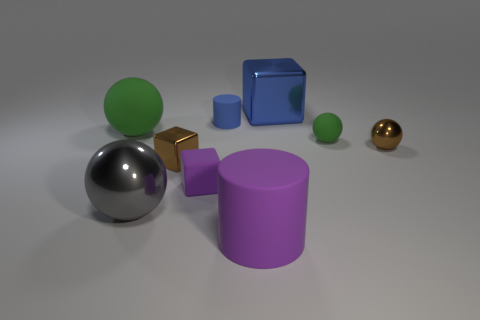Does the shiny sphere that is on the right side of the blue rubber thing have the same size as the large green object?
Your answer should be compact. No. Is the number of tiny red cubes greater than the number of shiny balls?
Your response must be concise. No. How many big objects are shiny objects or blue rubber cylinders?
Your answer should be very brief. 2. How many other things are there of the same color as the tiny rubber ball?
Your answer should be compact. 1. How many brown spheres have the same material as the tiny cylinder?
Offer a terse response. 0. There is a sphere behind the small green object; is it the same color as the matte cube?
Your answer should be very brief. No. How many green objects are tiny rubber blocks or small matte balls?
Ensure brevity in your answer.  1. Are there any other things that are the same material as the big blue block?
Keep it short and to the point. Yes. Is the material of the big thing that is behind the large matte sphere the same as the gray sphere?
Your response must be concise. Yes. How many objects are either brown metal blocks or green matte spheres to the right of the big blue object?
Give a very brief answer. 2. 